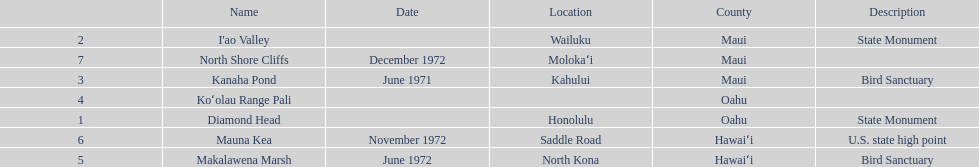What is the total number of state monuments? 2. 